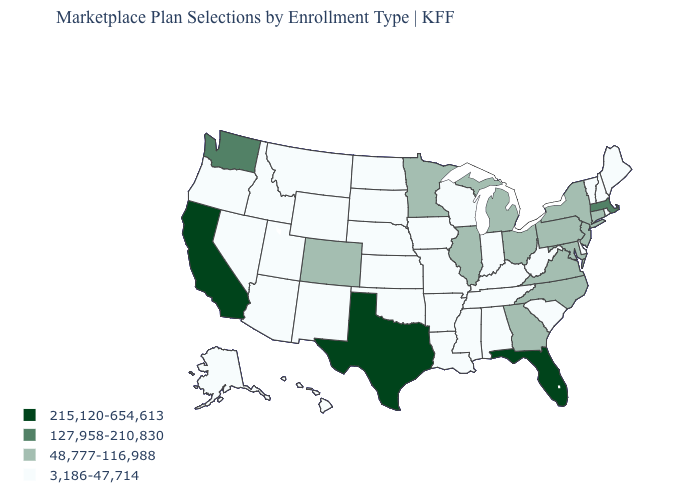How many symbols are there in the legend?
Answer briefly. 4. What is the lowest value in the USA?
Short answer required. 3,186-47,714. What is the lowest value in the USA?
Write a very short answer. 3,186-47,714. Name the states that have a value in the range 3,186-47,714?
Quick response, please. Alabama, Alaska, Arizona, Arkansas, Delaware, Hawaii, Idaho, Indiana, Iowa, Kansas, Kentucky, Louisiana, Maine, Mississippi, Missouri, Montana, Nebraska, Nevada, New Hampshire, New Mexico, North Dakota, Oklahoma, Oregon, Rhode Island, South Carolina, South Dakota, Tennessee, Utah, Vermont, West Virginia, Wisconsin, Wyoming. Among the states that border Louisiana , which have the highest value?
Be succinct. Texas. Among the states that border Illinois , which have the highest value?
Be succinct. Indiana, Iowa, Kentucky, Missouri, Wisconsin. Name the states that have a value in the range 127,958-210,830?
Concise answer only. Massachusetts, Washington. Is the legend a continuous bar?
Short answer required. No. Which states have the lowest value in the USA?
Short answer required. Alabama, Alaska, Arizona, Arkansas, Delaware, Hawaii, Idaho, Indiana, Iowa, Kansas, Kentucky, Louisiana, Maine, Mississippi, Missouri, Montana, Nebraska, Nevada, New Hampshire, New Mexico, North Dakota, Oklahoma, Oregon, Rhode Island, South Carolina, South Dakota, Tennessee, Utah, Vermont, West Virginia, Wisconsin, Wyoming. Name the states that have a value in the range 48,777-116,988?
Keep it brief. Colorado, Connecticut, Georgia, Illinois, Maryland, Michigan, Minnesota, New Jersey, New York, North Carolina, Ohio, Pennsylvania, Virginia. Which states hav the highest value in the MidWest?
Be succinct. Illinois, Michigan, Minnesota, Ohio. Name the states that have a value in the range 127,958-210,830?
Short answer required. Massachusetts, Washington. What is the lowest value in the Northeast?
Write a very short answer. 3,186-47,714. What is the value of Tennessee?
Quick response, please. 3,186-47,714. Does Hawaii have the lowest value in the West?
Be succinct. Yes. 